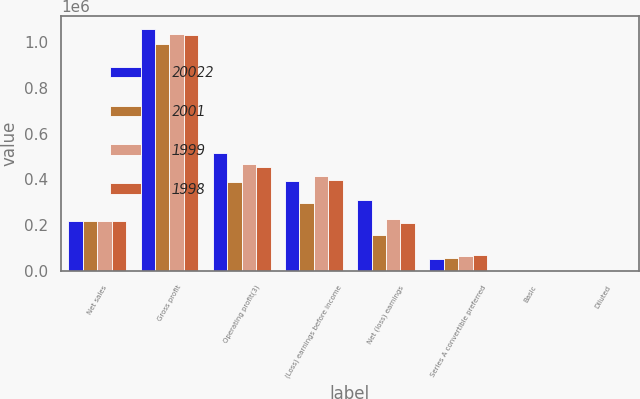Convert chart to OTSL. <chart><loc_0><loc_0><loc_500><loc_500><stacked_bar_chart><ecel><fcel>Net sales<fcel>Gross profit<fcel>Operating profit(3)<fcel>(Loss) earnings before income<fcel>Net (loss) earnings<fcel>Series A convertible preferred<fcel>Basic<fcel>Diluted<nl><fcel>20022<fcel>218390<fcel>1.05761e+06<fcel>516386<fcel>391933<fcel>309069<fcel>53845<fcel>4.2<fcel>4.3<nl><fcel>2001<fcel>218390<fcel>990287<fcel>387391<fcel>297452<fcel>156697<fcel>55024<fcel>1.3<fcel>1.22<nl><fcel>1999<fcel>218390<fcel>1.0353e+06<fcel>468463<fcel>413429<fcel>225319<fcel>64266<fcel>2.47<fcel>1.93<nl><fcel>1998<fcel>218390<fcel>1.02872e+06<fcel>452192<fcel>395653<fcel>211461<fcel>71422<fcel>1.69<fcel>1.68<nl></chart> 